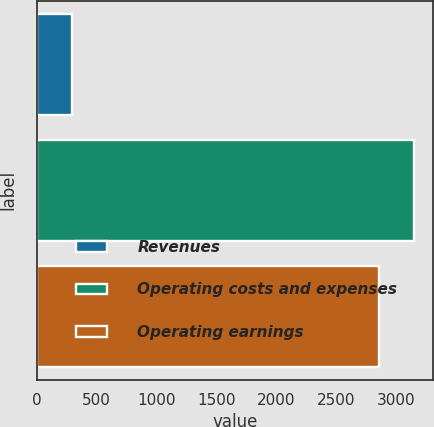Convert chart. <chart><loc_0><loc_0><loc_500><loc_500><bar_chart><fcel>Revenues<fcel>Operating costs and expenses<fcel>Operating earnings<nl><fcel>295<fcel>3147<fcel>2852<nl></chart> 